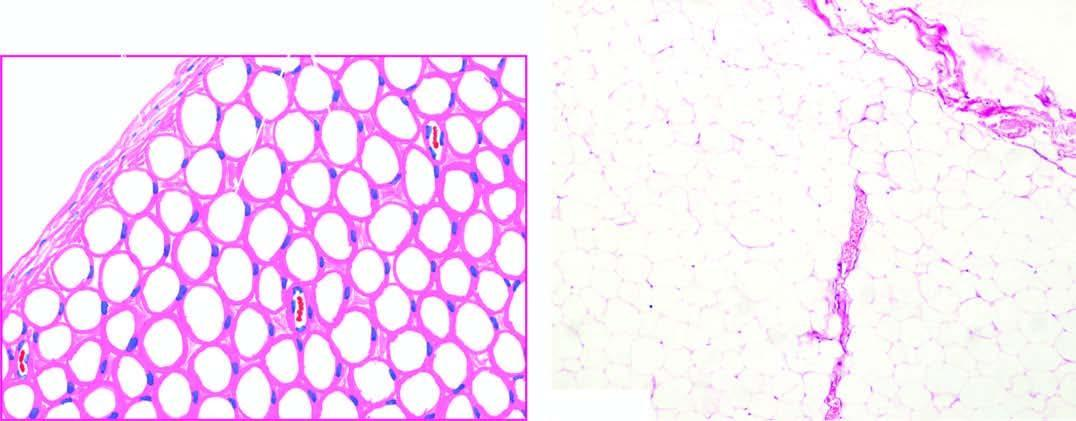what does the tumour show?
Answer the question using a single word or phrase. A thin capsule and underlying lobules of mature adipose cells separated by delicate fibrous septa 